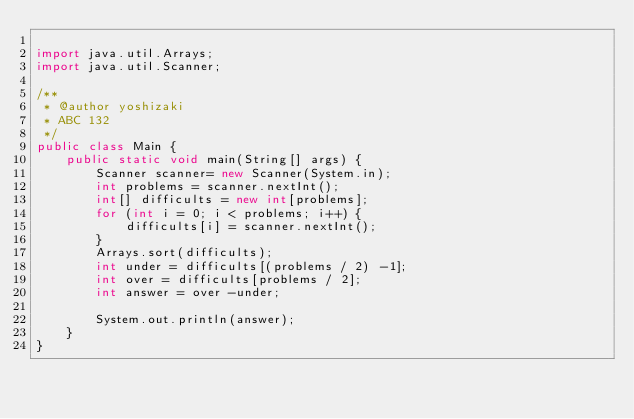<code> <loc_0><loc_0><loc_500><loc_500><_Java_>
import java.util.Arrays;
import java.util.Scanner;

/**
 * @author yoshizaki
 * ABC 132
 */
public class Main {
    public static void main(String[] args) {
        Scanner scanner= new Scanner(System.in);
        int problems = scanner.nextInt();
        int[] difficults = new int[problems];
        for (int i = 0; i < problems; i++) {
            difficults[i] = scanner.nextInt();
        }
        Arrays.sort(difficults);
        int under = difficults[(problems / 2) -1];
        int over = difficults[problems / 2];
        int answer = over -under;
        
        System.out.println(answer);
    }
}
</code> 